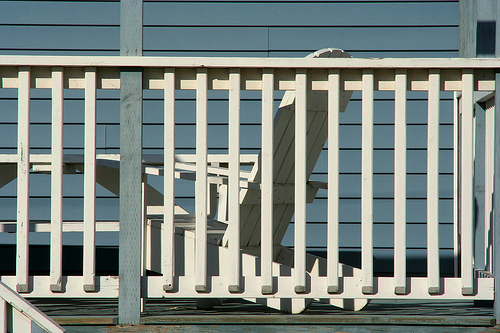<image>
Is there a chair behind the fence? Yes. From this viewpoint, the chair is positioned behind the fence, with the fence partially or fully occluding the chair. 